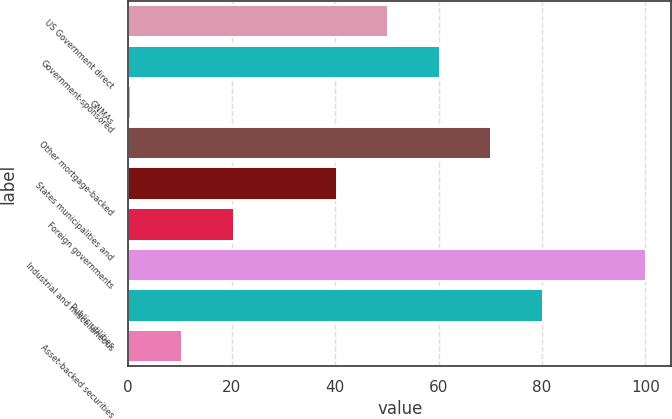Convert chart to OTSL. <chart><loc_0><loc_0><loc_500><loc_500><bar_chart><fcel>US Government direct<fcel>Government-sponsored<fcel>GNMAs<fcel>Other mortgage-backed<fcel>States municipalities and<fcel>Foreign governments<fcel>Industrial and miscellaneous<fcel>Public utilities<fcel>Asset-backed securities<nl><fcel>50.26<fcel>60.21<fcel>0.51<fcel>70.16<fcel>40.31<fcel>20.41<fcel>100.01<fcel>80.11<fcel>10.46<nl></chart> 